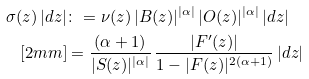Convert formula to latex. <formula><loc_0><loc_0><loc_500><loc_500>\sigma ( z ) \, | d z | & \colon = \nu ( z ) \, | B ( z ) | ^ { | \alpha | } \, | O ( z ) | ^ { | \alpha | } \, | d z | \\ [ 2 m m ] & = \frac { ( \alpha + 1 ) } { | S ( z ) | ^ { | \alpha | } } \, \frac { | F ^ { \prime } ( z ) | } { 1 - | F ( z ) | ^ { 2 ( \alpha + 1 ) } } \, | d z |</formula> 